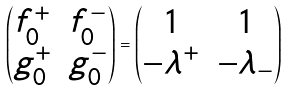<formula> <loc_0><loc_0><loc_500><loc_500>\left ( \begin{matrix} f ^ { + } _ { 0 } & f ^ { - } _ { 0 } \\ g ^ { + } _ { 0 } & g ^ { - } _ { 0 } \\ \end{matrix} \right ) = \begin{pmatrix} 1 & 1 \\ - \lambda ^ { + } & - \lambda _ { - } \\ \end{pmatrix}</formula> 